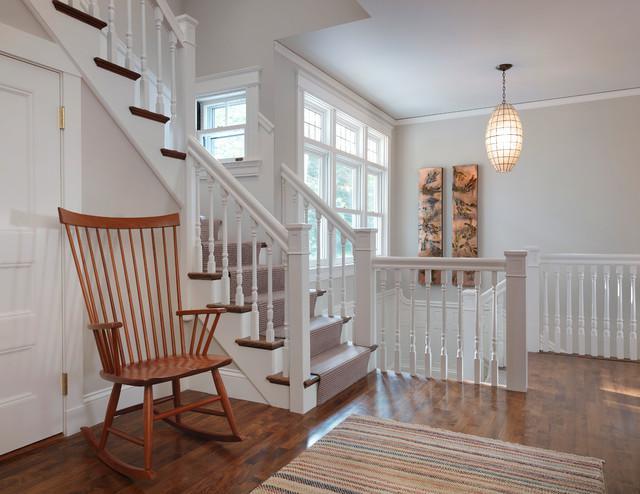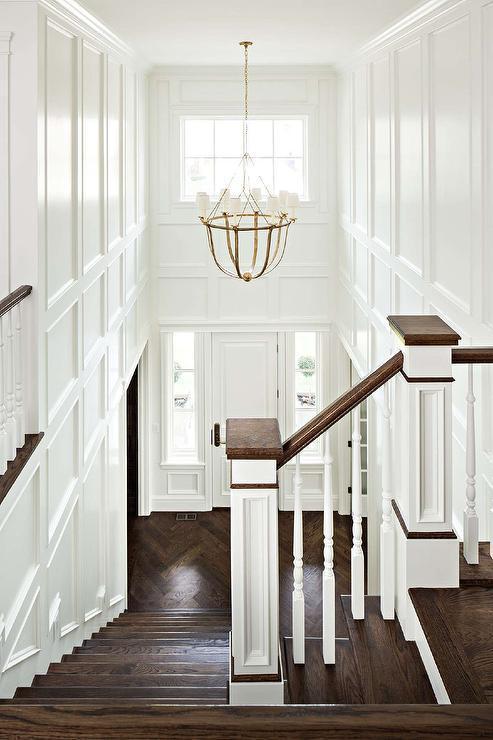The first image is the image on the left, the second image is the image on the right. Evaluate the accuracy of this statement regarding the images: "there is a stairway with windows and a chandelier hanging from the ceiling". Is it true? Answer yes or no. Yes. The first image is the image on the left, the second image is the image on the right. Considering the images on both sides, is "The left image shows one non-turning flight of carpeted stairs, with spindle rails and a ball atop the end post." valid? Answer yes or no. No. 